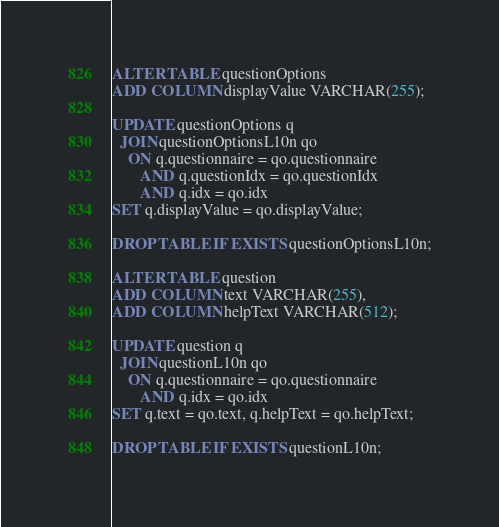<code> <loc_0><loc_0><loc_500><loc_500><_SQL_>ALTER TABLE questionOptions
ADD COLUMN displayValue VARCHAR(255);

UPDATE questionOptions q
  JOIN questionOptionsL10n qo
    ON q.questionnaire = qo.questionnaire
       AND q.questionIdx = qo.questionIdx
       AND q.idx = qo.idx
SET q.displayValue = qo.displayValue;

DROP TABLE IF EXISTS questionOptionsL10n;

ALTER TABLE question
ADD COLUMN text VARCHAR(255),
ADD COLUMN helpText VARCHAR(512);

UPDATE question q
  JOIN questionL10n qo
    ON q.questionnaire = qo.questionnaire
       AND q.idx = qo.idx
SET q.text = qo.text, q.helpText = qo.helpText;

DROP TABLE IF EXISTS questionL10n;
</code> 